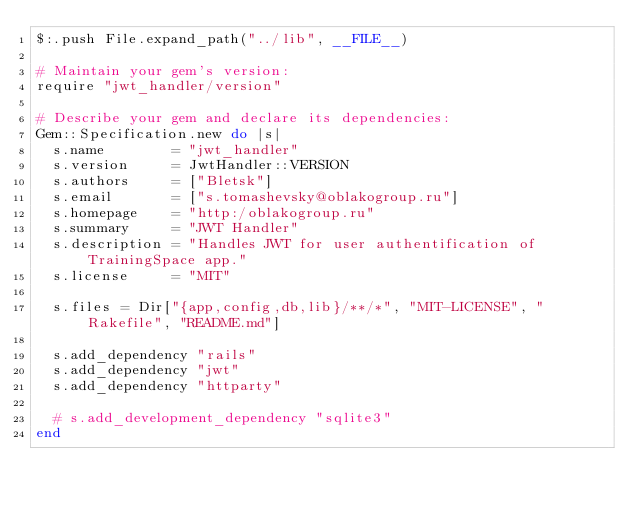<code> <loc_0><loc_0><loc_500><loc_500><_Ruby_>$:.push File.expand_path("../lib", __FILE__)

# Maintain your gem's version:
require "jwt_handler/version"

# Describe your gem and declare its dependencies:
Gem::Specification.new do |s|
  s.name        = "jwt_handler"
  s.version     = JwtHandler::VERSION
  s.authors     = ["Bletsk"]
  s.email       = ["s.tomashevsky@oblakogroup.ru"]
  s.homepage    = "http:/oblakogroup.ru"
  s.summary     = "JWT Handler"
  s.description = "Handles JWT for user authentification of TrainingSpace app."
  s.license     = "MIT"

  s.files = Dir["{app,config,db,lib}/**/*", "MIT-LICENSE", "Rakefile", "README.md"]

  s.add_dependency "rails"
  s.add_dependency "jwt"
  s.add_dependency "httparty"

  # s.add_development_dependency "sqlite3"
end
</code> 